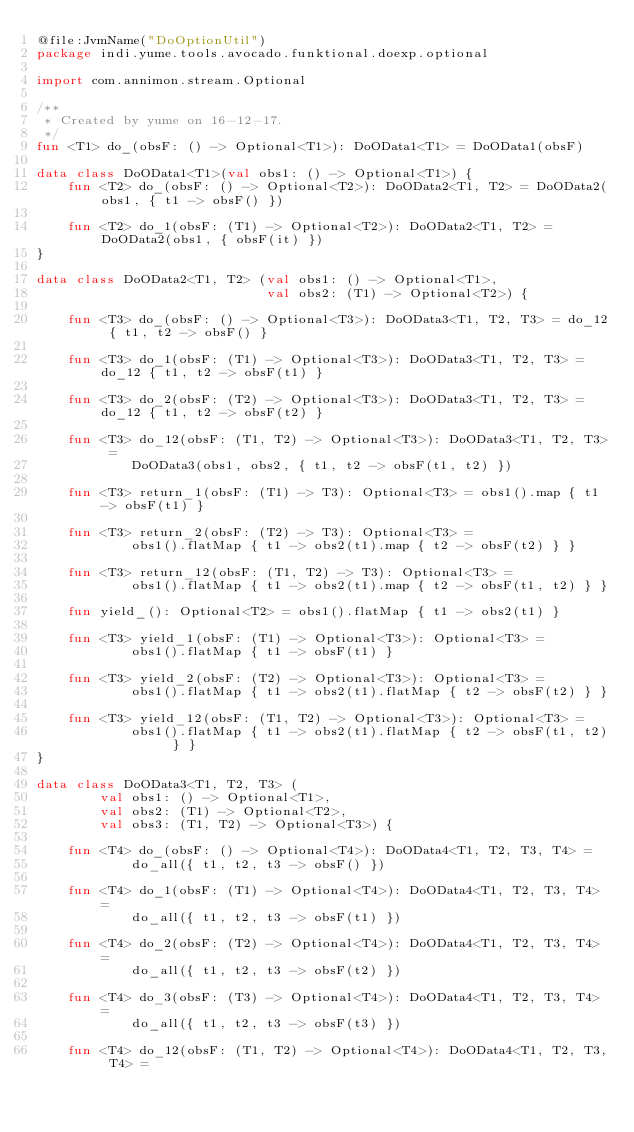Convert code to text. <code><loc_0><loc_0><loc_500><loc_500><_Kotlin_>@file:JvmName("DoOptionUtil")
package indi.yume.tools.avocado.funktional.doexp.optional

import com.annimon.stream.Optional

/**
 * Created by yume on 16-12-17.
 */
fun <T1> do_(obsF: () -> Optional<T1>): DoOData1<T1> = DoOData1(obsF)

data class DoOData1<T1>(val obs1: () -> Optional<T1>) {
    fun <T2> do_(obsF: () -> Optional<T2>): DoOData2<T1, T2> = DoOData2(obs1, { t1 -> obsF() })

    fun <T2> do_1(obsF: (T1) -> Optional<T2>): DoOData2<T1, T2> = DoOData2(obs1, { obsF(it) })
}

data class DoOData2<T1, T2> (val obs1: () -> Optional<T1>,
                             val obs2: (T1) -> Optional<T2>) {

    fun <T3> do_(obsF: () -> Optional<T3>): DoOData3<T1, T2, T3> = do_12 { t1, t2 -> obsF() }

    fun <T3> do_1(obsF: (T1) -> Optional<T3>): DoOData3<T1, T2, T3> = do_12 { t1, t2 -> obsF(t1) }

    fun <T3> do_2(obsF: (T2) -> Optional<T3>): DoOData3<T1, T2, T3> = do_12 { t1, t2 -> obsF(t2) }

    fun <T3> do_12(obsF: (T1, T2) -> Optional<T3>): DoOData3<T1, T2, T3> =
            DoOData3(obs1, obs2, { t1, t2 -> obsF(t1, t2) })

    fun <T3> return_1(obsF: (T1) -> T3): Optional<T3> = obs1().map { t1 -> obsF(t1) }

    fun <T3> return_2(obsF: (T2) -> T3): Optional<T3> =
            obs1().flatMap { t1 -> obs2(t1).map { t2 -> obsF(t2) } }

    fun <T3> return_12(obsF: (T1, T2) -> T3): Optional<T3> =
            obs1().flatMap { t1 -> obs2(t1).map { t2 -> obsF(t1, t2) } }

    fun yield_(): Optional<T2> = obs1().flatMap { t1 -> obs2(t1) }

    fun <T3> yield_1(obsF: (T1) -> Optional<T3>): Optional<T3> =
            obs1().flatMap { t1 -> obsF(t1) }

    fun <T3> yield_2(obsF: (T2) -> Optional<T3>): Optional<T3> =
            obs1().flatMap { t1 -> obs2(t1).flatMap { t2 -> obsF(t2) } }

    fun <T3> yield_12(obsF: (T1, T2) -> Optional<T3>): Optional<T3> =
            obs1().flatMap { t1 -> obs2(t1).flatMap { t2 -> obsF(t1, t2) } }
}

data class DoOData3<T1, T2, T3> (
        val obs1: () -> Optional<T1>,
        val obs2: (T1) -> Optional<T2>,
        val obs3: (T1, T2) -> Optional<T3>) {

    fun <T4> do_(obsF: () -> Optional<T4>): DoOData4<T1, T2, T3, T4> =
            do_all({ t1, t2, t3 -> obsF() })

    fun <T4> do_1(obsF: (T1) -> Optional<T4>): DoOData4<T1, T2, T3, T4> =
            do_all({ t1, t2, t3 -> obsF(t1) })

    fun <T4> do_2(obsF: (T2) -> Optional<T4>): DoOData4<T1, T2, T3, T4> =
            do_all({ t1, t2, t3 -> obsF(t2) })

    fun <T4> do_3(obsF: (T3) -> Optional<T4>): DoOData4<T1, T2, T3, T4> =
            do_all({ t1, t2, t3 -> obsF(t3) })

    fun <T4> do_12(obsF: (T1, T2) -> Optional<T4>): DoOData4<T1, T2, T3, T4> =</code> 